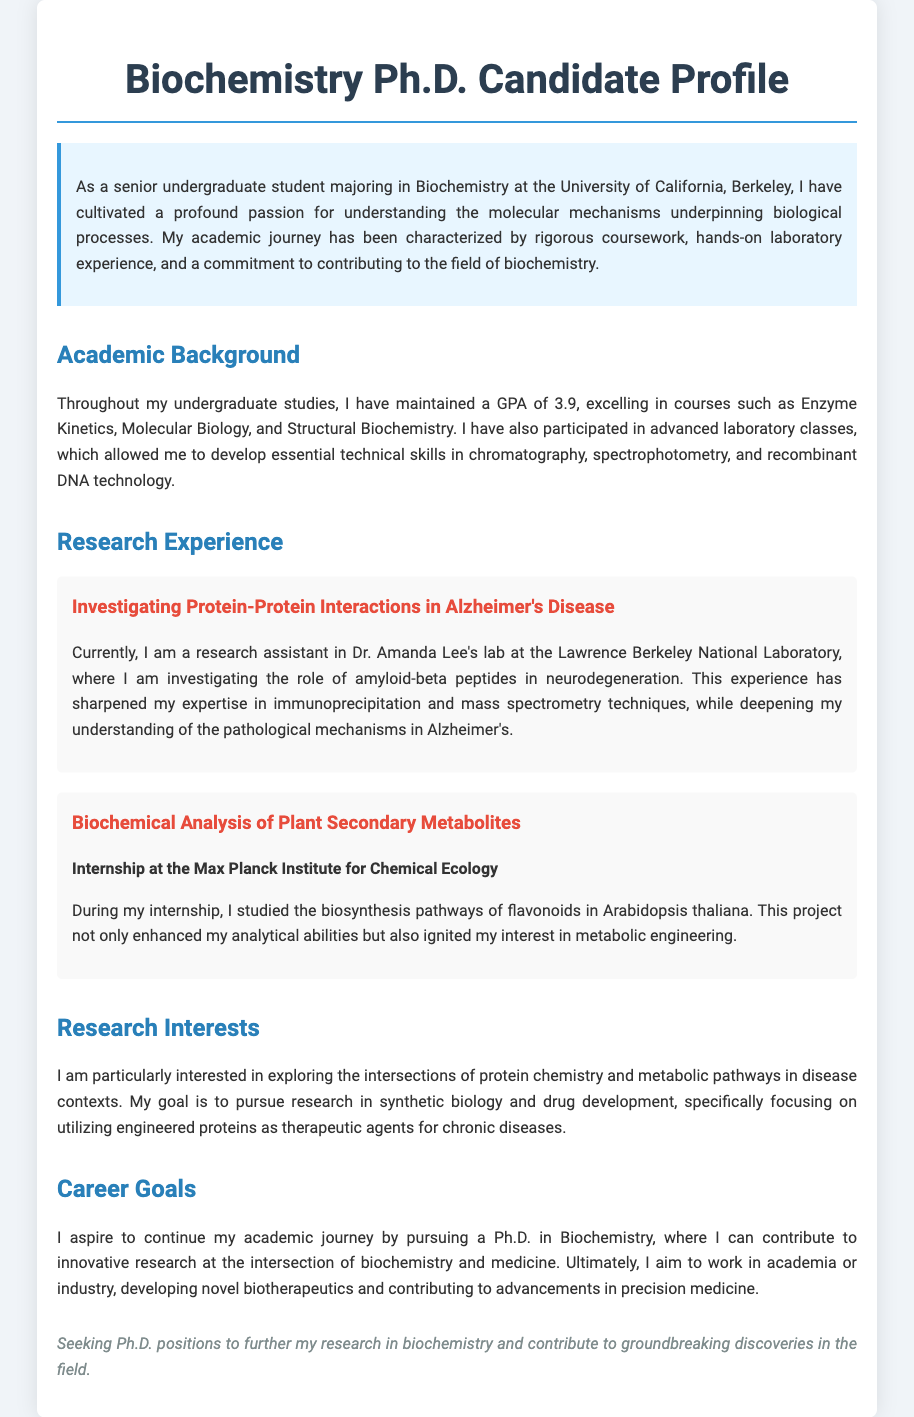What is the GPA achieved by the candidate? The GPA is mentioned in the Academic Background section of the document as 3.9.
Answer: 3.9 Who is the research assistant working with? The document states that the candidate is a research assistant in Dr. Amanda Lee's lab.
Answer: Dr. Amanda Lee What research project focuses on Alzheimer’s disease? The document specifies the project titled "Investigating Protein-Protein Interactions in Alzheimer's Disease."
Answer: Investigating Protein-Protein Interactions in Alzheimer's Disease What are the candidate's research interests primarily focused on? The Research Interests section describes the candidate's focus on protein chemistry and metabolic pathways in disease contexts.
Answer: protein chemistry and metabolic pathways Which institution did the candidate intern at for studying flavonoids? The document indicates that the candidate interned at the Max Planck Institute for Chemical Ecology.
Answer: Max Planck Institute for Chemical Ecology What are the candidate's career goals related to? The Career Goals section mentions the aspiration to develop novel biotherapeutics and contribute to advancements in precision medicine.
Answer: novel biotherapeutics and advancements in precision medicine How many advanced laboratory classes did the candidate participate in? The document mentions participation in advanced laboratory classes but does not specify a number.
Answer: Not specified What specific techniques has the candidate gained expertise in? The research projects listed the techniques as immunoprecipitation and mass spectrometry.
Answer: immunoprecipitation and mass spectrometry What is the overarching theme of the candidate's academic journey? The document highlights a commitment to contributing to the field of biochemistry throughout the candidate's academic journey.
Answer: contributing to the field of biochemistry 